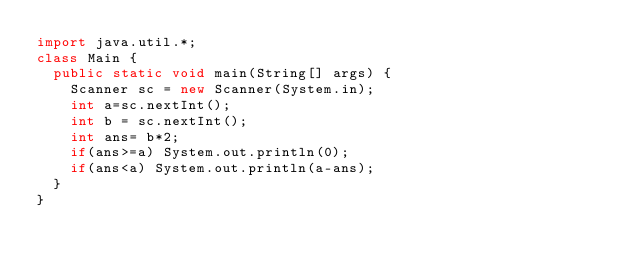<code> <loc_0><loc_0><loc_500><loc_500><_Java_>import java.util.*;
class Main {
  public static void main(String[] args) {
    Scanner sc = new Scanner(System.in);
    int a=sc.nextInt();
    int b = sc.nextInt();
    int ans= b*2;
    if(ans>=a) System.out.println(0);
    if(ans<a) System.out.println(a-ans);
  }
}</code> 